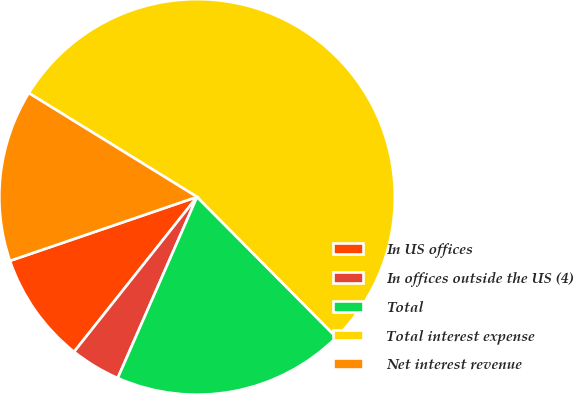Convert chart to OTSL. <chart><loc_0><loc_0><loc_500><loc_500><pie_chart><fcel>In US offices<fcel>In offices outside the US (4)<fcel>Total<fcel>Total interest expense<fcel>Net interest revenue<nl><fcel>9.08%<fcel>4.11%<fcel>19.01%<fcel>53.76%<fcel>14.04%<nl></chart> 